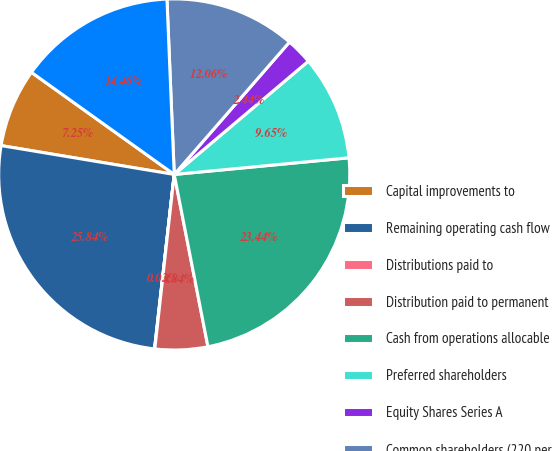Convert chart. <chart><loc_0><loc_0><loc_500><loc_500><pie_chart><fcel>Capital improvements to<fcel>Remaining operating cash flow<fcel>Distributions paid to<fcel>Distribution paid to permanent<fcel>Cash from operations allocable<fcel>Preferred shareholders<fcel>Equity Shares Series A<fcel>Common shareholders (220 per<fcel>Cash from operations available<nl><fcel>7.25%<fcel>25.84%<fcel>0.03%<fcel>4.84%<fcel>23.44%<fcel>9.65%<fcel>2.44%<fcel>12.06%<fcel>14.46%<nl></chart> 